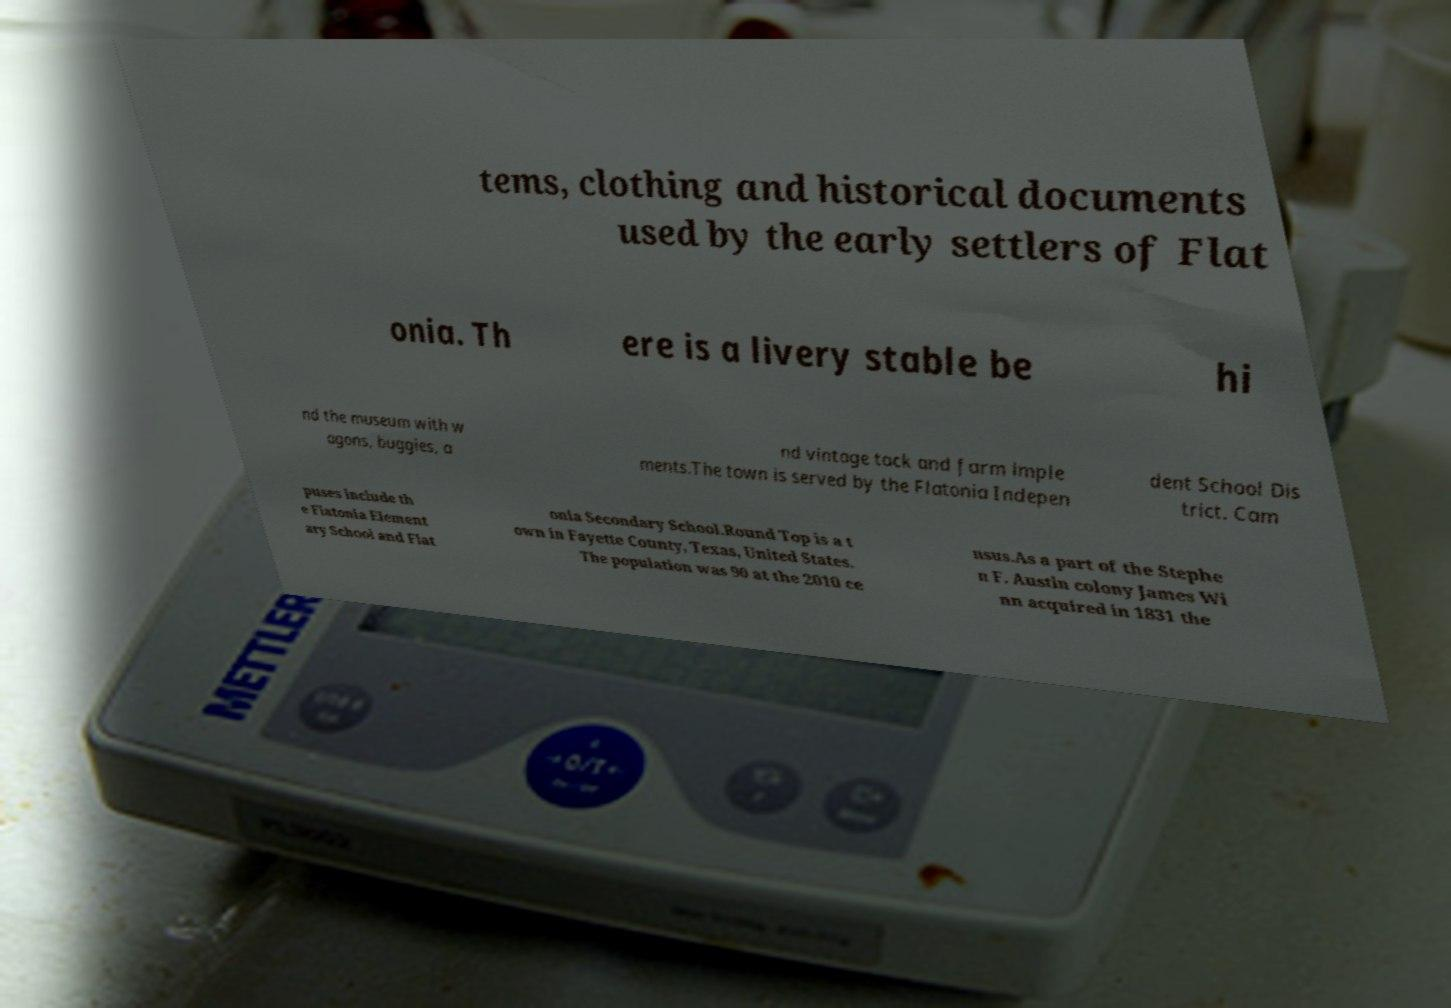What messages or text are displayed in this image? I need them in a readable, typed format. tems, clothing and historical documents used by the early settlers of Flat onia. Th ere is a livery stable be hi nd the museum with w agons, buggies, a nd vintage tack and farm imple ments.The town is served by the Flatonia Indepen dent School Dis trict. Cam puses include th e Flatonia Element ary School and Flat onia Secondary School.Round Top is a t own in Fayette County, Texas, United States. The population was 90 at the 2010 ce nsus.As a part of the Stephe n F. Austin colony James Wi nn acquired in 1831 the 